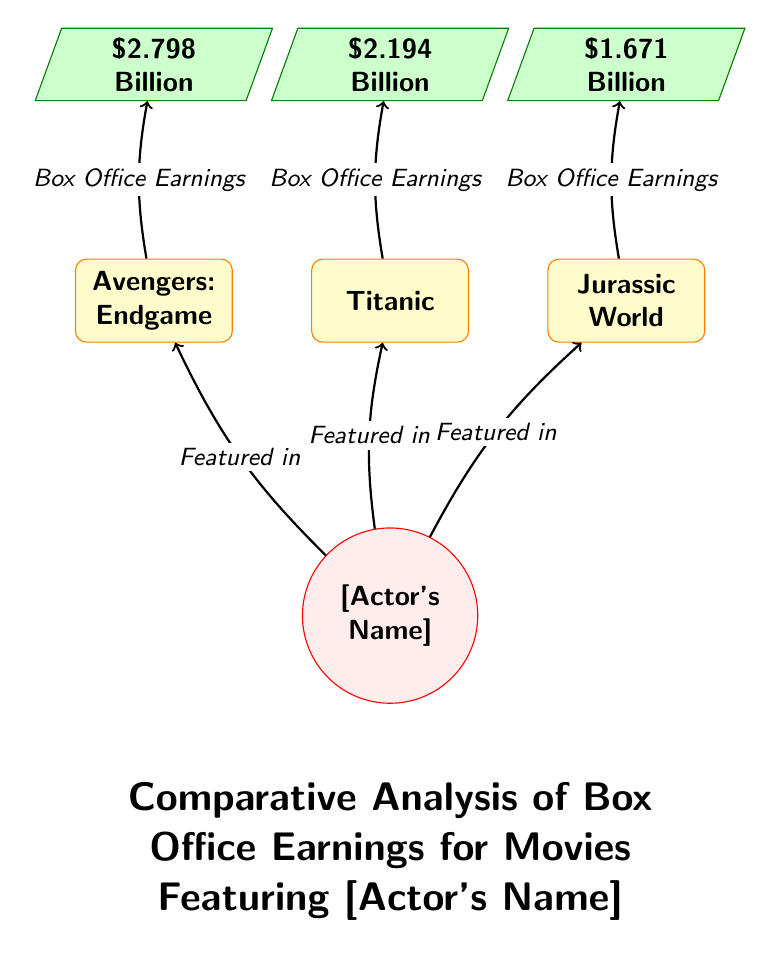What is the box office earning of Avengers: Endgame? The diagram specifically shows the earnings for each movie featuring the actor. By following the connection from the movie node "Avengers: Endgame" to its corresponding earnings node, we see that it states "$2.798 Billion".
Answer: $2.798 Billion How many movies feature the actor? The actor is connected to three different movie nodes in the diagram: "Avengers: Endgame", "Titanic", and "Jurassic World". Counting these, we find there are three movies that feature the actor.
Answer: 3 What is the box office earning of Titanic? Similar to the first question, we trace the connection from the movie node "Titanic" to its earnings node. The diagram shows that "Titanic" earned "$2.194 Billion".
Answer: $2.194 Billion Which movie has the highest box office earnings? To find this, we compare the box office earnings presented in the diagram for all three movies. "Avengers: Endgame" at "$2.798 Billion" is greater than both "Titanic" at "$2.194 Billion" and "Jurassic World" at "$1.671 Billion", making it the highest earning.
Answer: Avengers: Endgame How are the earnings represented in the diagram? The diagram uses trapezium-shaped nodes specifically for representing box office earnings, filled with a green color and labeled with the respective earning amounts next to each movie node.
Answer: Trapezium How many connections lead from the actor node to the movie nodes? In the diagram, there are three directional arrows (connections) coming from the actor node to the movie nodes, each indicating that the actor is featured in those movies. Thus, there are three connections.
Answer: 3 What is the box office earning of Jurassic World? By following the arrow from the "Jurassic World" movie node to its corresponding earnings node, it states "$1.671 Billion". This gives us the box office earnings for that particular movie.
Answer: $1.671 Billion Which node style represents box office earnings? The trapezium node style is used in the diagram to specifically represent the box office earnings, illustrated with a green color and shape, distinguishing it from the movie and actor nodes.
Answer: Trapezium 